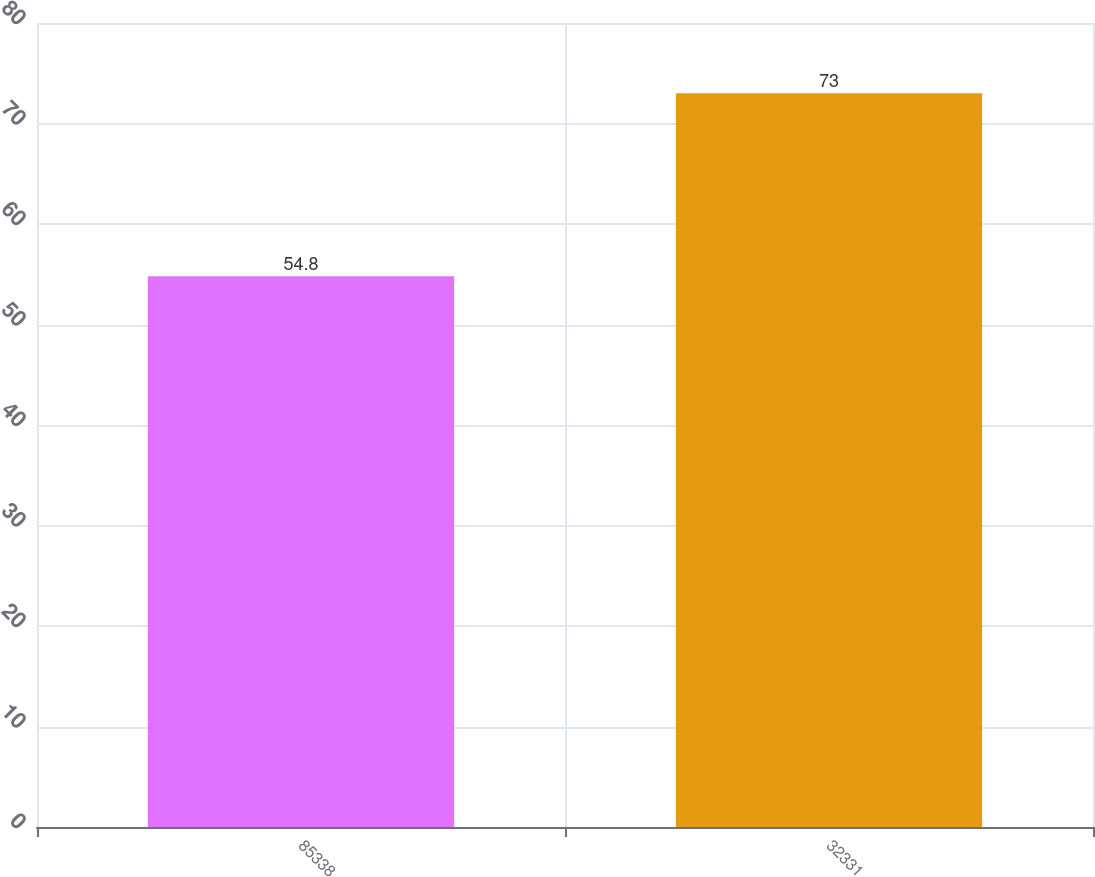<chart> <loc_0><loc_0><loc_500><loc_500><bar_chart><fcel>85338<fcel>32331<nl><fcel>54.8<fcel>73<nl></chart> 